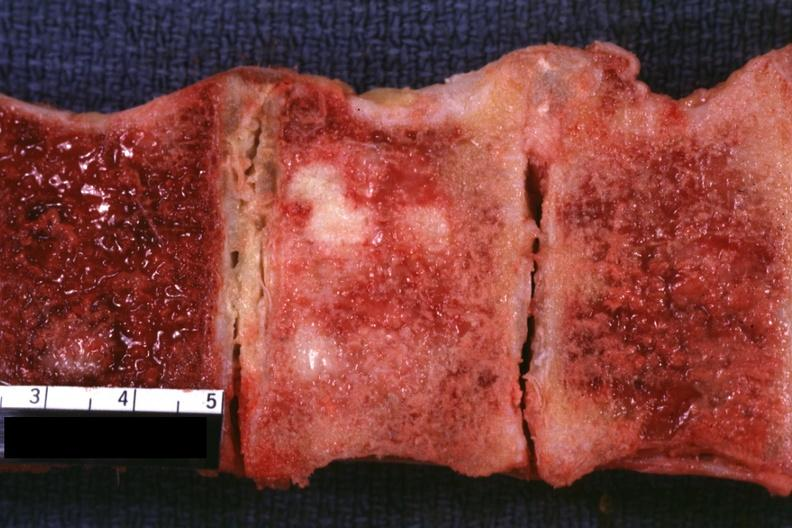what is present?
Answer the question using a single word or phrase. Joints 